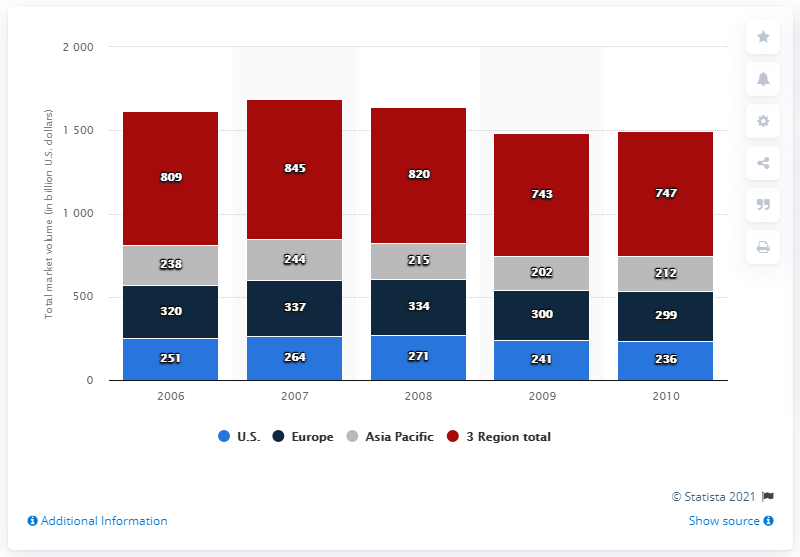Indicate a few pertinent items in this graphic. The total volume of the U.S. travel market in 2006 was 251. The travel market in the Asia Pacific region is the largest in size. The average size of travel in the United States is approximately 252.6 square feet. 